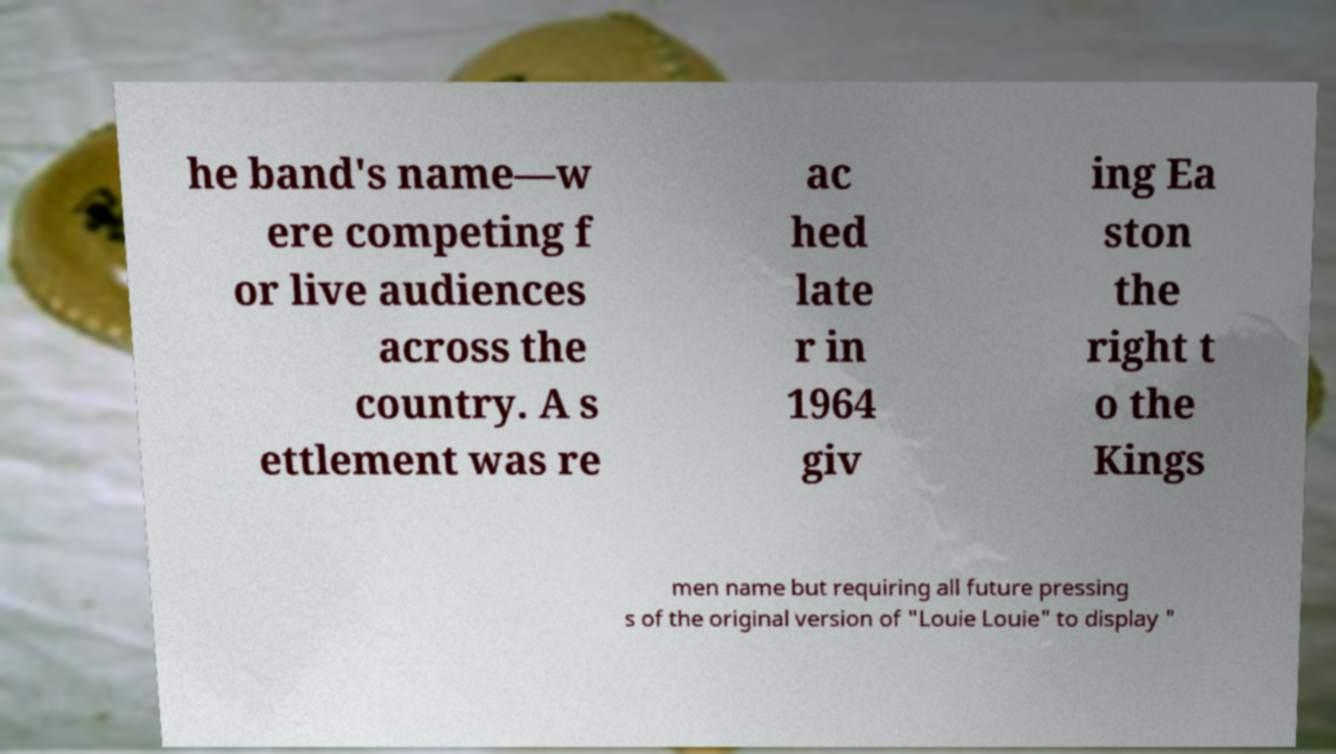Could you extract and type out the text from this image? he band's name—w ere competing f or live audiences across the country. A s ettlement was re ac hed late r in 1964 giv ing Ea ston the right t o the Kings men name but requiring all future pressing s of the original version of "Louie Louie" to display " 